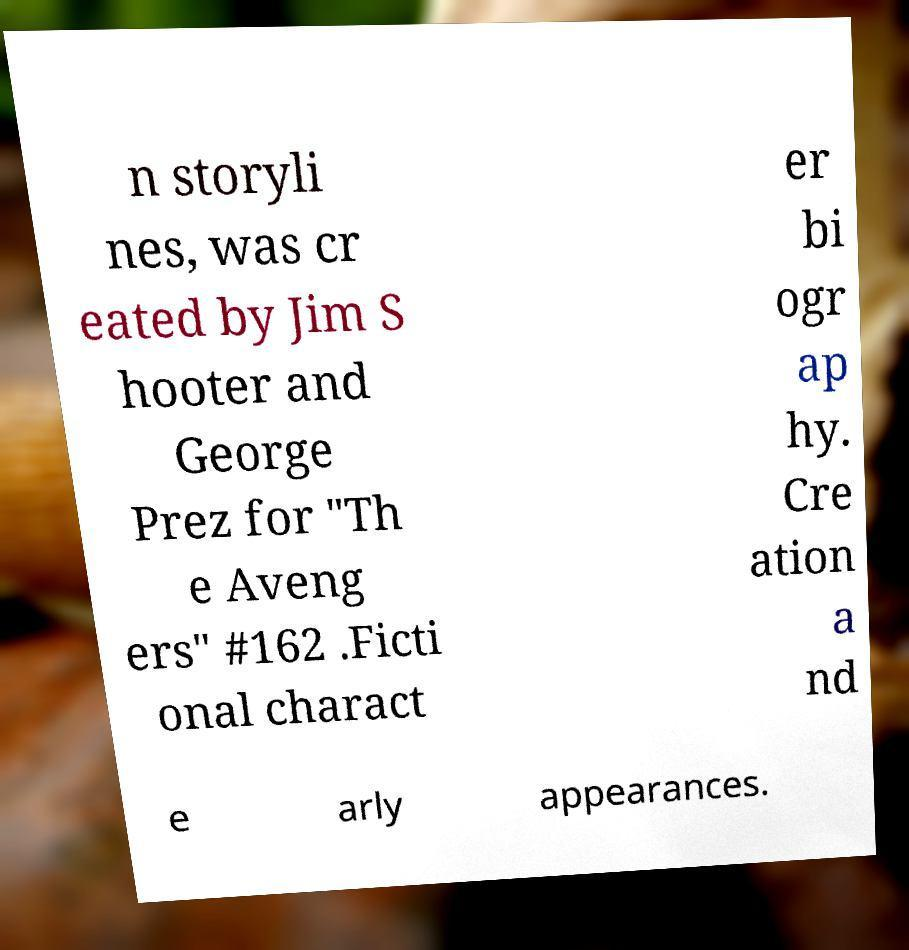Please read and relay the text visible in this image. What does it say? n storyli nes, was cr eated by Jim S hooter and George Prez for "Th e Aveng ers" #162 .Ficti onal charact er bi ogr ap hy. Cre ation a nd e arly appearances. 